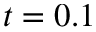<formula> <loc_0><loc_0><loc_500><loc_500>t = 0 . 1</formula> 